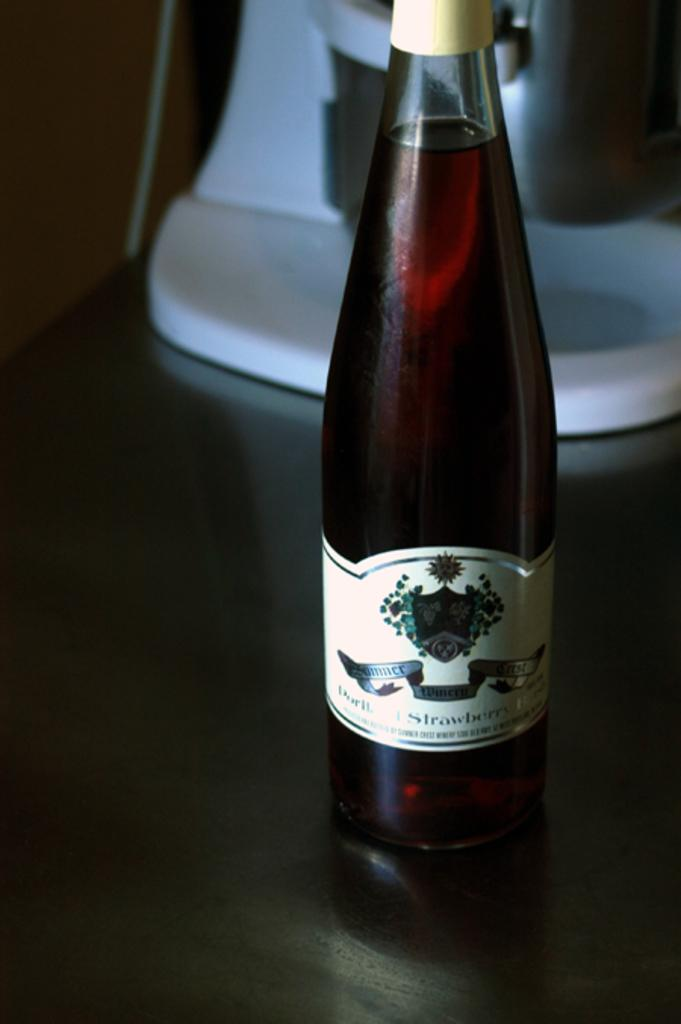What object can be seen in the image? There is a bottle in the image. How many bears are visible in the image? There are no bears present in the image; it only features a bottle. Can you tell me what type of camera was used to take the picture? There is no information about the camera used to take the picture, as the focus is solely on the bottle in the image. 